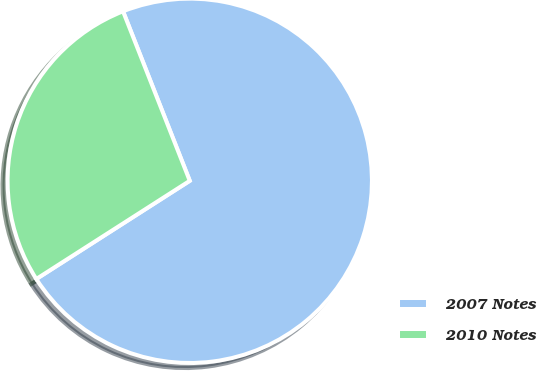<chart> <loc_0><loc_0><loc_500><loc_500><pie_chart><fcel>2007 Notes<fcel>2010 Notes<nl><fcel>71.91%<fcel>28.09%<nl></chart> 